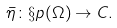Convert formula to latex. <formula><loc_0><loc_0><loc_500><loc_500>\bar { \eta } \colon \S p ( \Omega ) \rightarrow C .</formula> 